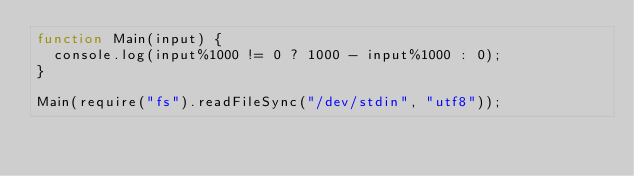<code> <loc_0><loc_0><loc_500><loc_500><_JavaScript_>function Main(input) {
  console.log(input%1000 != 0 ? 1000 - input%1000 : 0);
}

Main(require("fs").readFileSync("/dev/stdin", "utf8"));</code> 